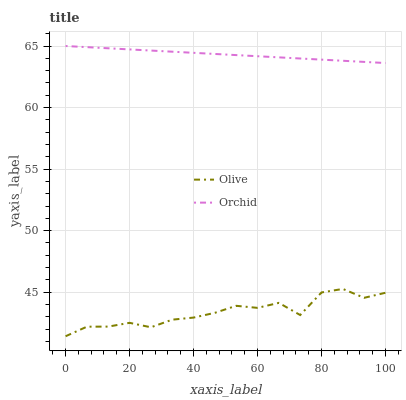Does Olive have the minimum area under the curve?
Answer yes or no. Yes. Does Orchid have the maximum area under the curve?
Answer yes or no. Yes. Does Orchid have the minimum area under the curve?
Answer yes or no. No. Is Orchid the smoothest?
Answer yes or no. Yes. Is Olive the roughest?
Answer yes or no. Yes. Is Orchid the roughest?
Answer yes or no. No. Does Olive have the lowest value?
Answer yes or no. Yes. Does Orchid have the lowest value?
Answer yes or no. No. Does Orchid have the highest value?
Answer yes or no. Yes. Is Olive less than Orchid?
Answer yes or no. Yes. Is Orchid greater than Olive?
Answer yes or no. Yes. Does Olive intersect Orchid?
Answer yes or no. No. 